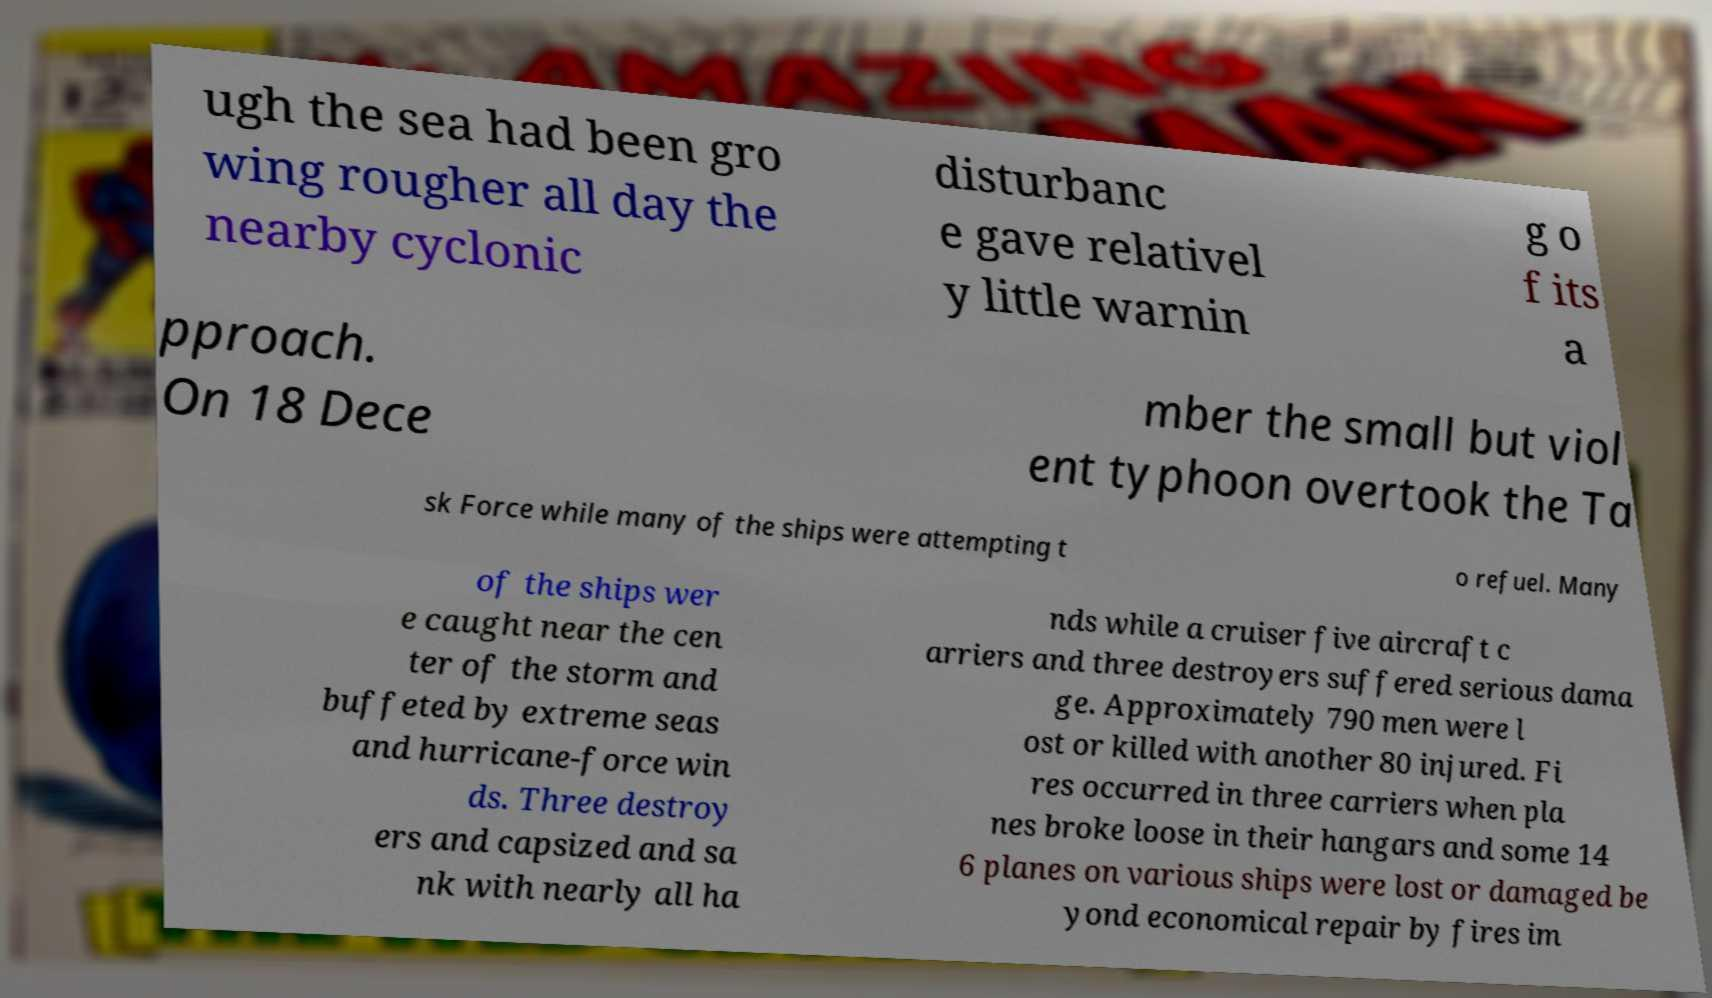Can you read and provide the text displayed in the image?This photo seems to have some interesting text. Can you extract and type it out for me? ugh the sea had been gro wing rougher all day the nearby cyclonic disturbanc e gave relativel y little warnin g o f its a pproach. On 18 Dece mber the small but viol ent typhoon overtook the Ta sk Force while many of the ships were attempting t o refuel. Many of the ships wer e caught near the cen ter of the storm and buffeted by extreme seas and hurricane-force win ds. Three destroy ers and capsized and sa nk with nearly all ha nds while a cruiser five aircraft c arriers and three destroyers suffered serious dama ge. Approximately 790 men were l ost or killed with another 80 injured. Fi res occurred in three carriers when pla nes broke loose in their hangars and some 14 6 planes on various ships were lost or damaged be yond economical repair by fires im 